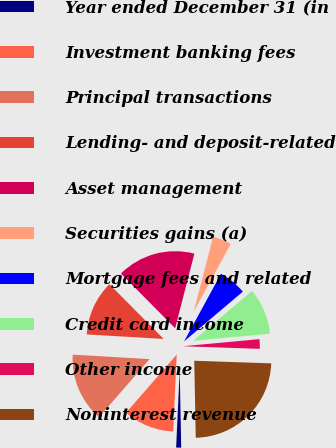Convert chart to OTSL. <chart><loc_0><loc_0><loc_500><loc_500><pie_chart><fcel>Year ended December 31 (in<fcel>Investment banking fees<fcel>Principal transactions<fcel>Lending- and deposit-related<fcel>Asset management<fcel>Securities gains (a)<fcel>Mortgage fees and related<fcel>Credit card income<fcel>Other income<fcel>Noninterest revenue<nl><fcel>1.05%<fcel>10.67%<fcel>14.52%<fcel>11.64%<fcel>16.45%<fcel>3.94%<fcel>5.86%<fcel>9.71%<fcel>2.01%<fcel>24.15%<nl></chart> 